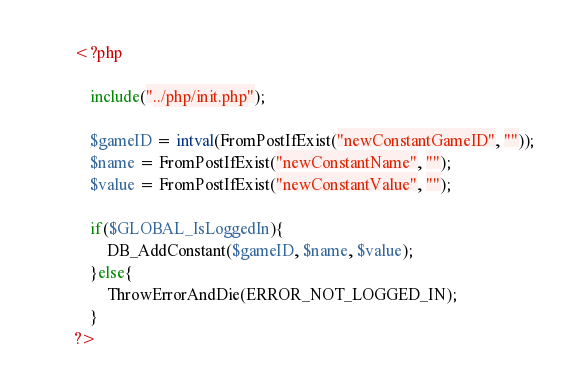<code> <loc_0><loc_0><loc_500><loc_500><_PHP_><?php

	include("../php/init.php");
	
	$gameID = intval(FromPostIfExist("newConstantGameID", ""));
	$name = FromPostIfExist("newConstantName", "");
	$value = FromPostIfExist("newConstantValue", "");
	
	if($GLOBAL_IsLoggedIn){
		DB_AddConstant($gameID, $name, $value);
	}else{
		ThrowErrorAndDie(ERROR_NOT_LOGGED_IN);
	}
?></code> 